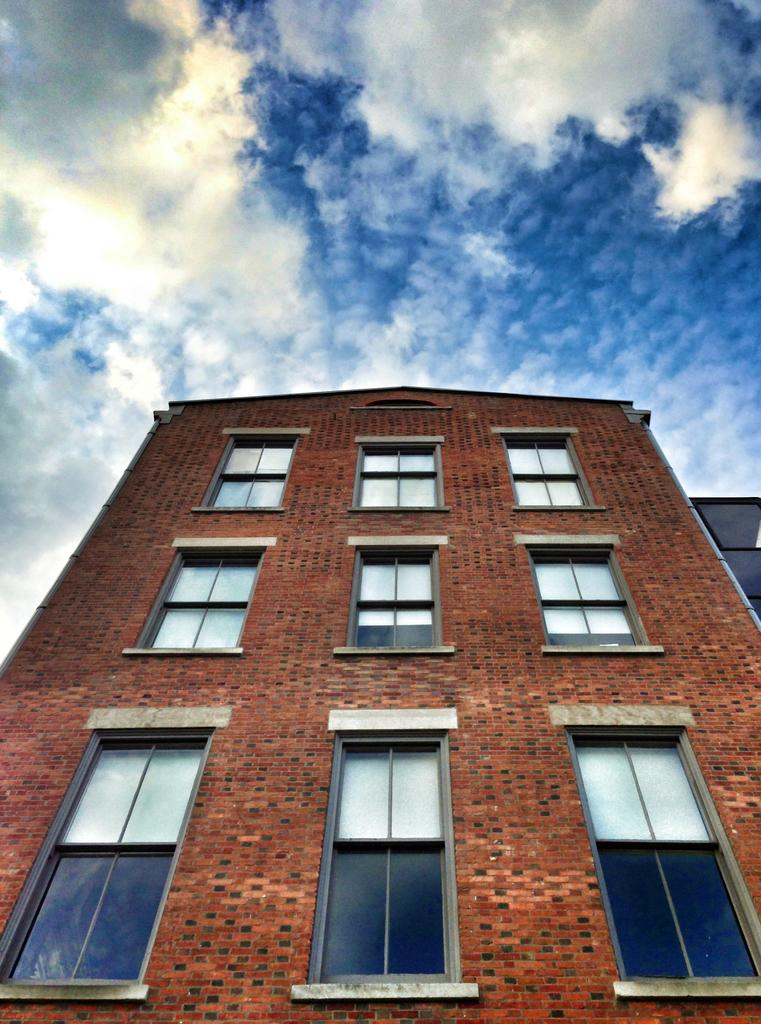What type of building is in the image? There is a big brown color building in the image. What can be observed about the building's windows? The building has many glass windows. Where is the building located in the image? The building is in the middle of the image. What is the condition of the sky in the image? The sky is blue and clear in the image. What hobbies are the clouds in the image participating in? There are no clouds present in the image, so it is not possible to determine any hobbies they might be participating in. 